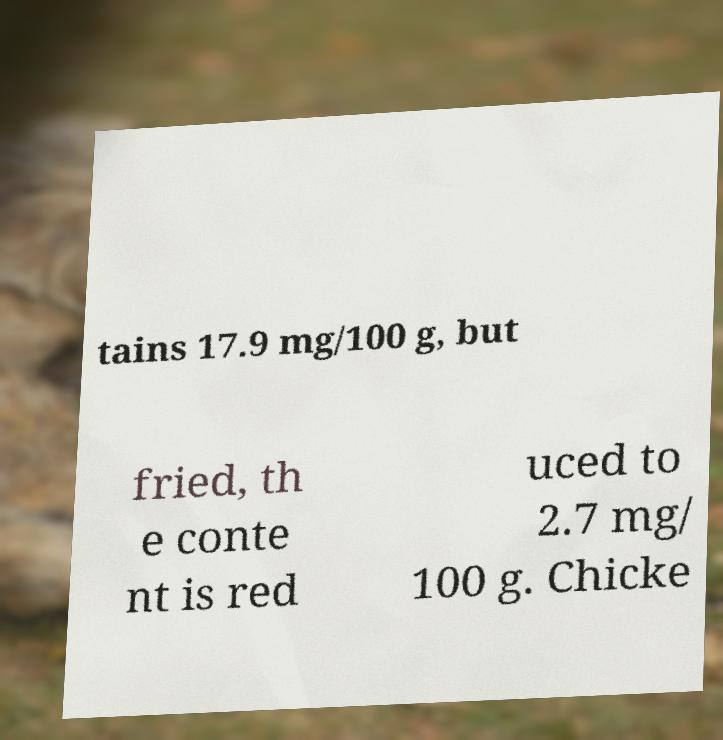Could you extract and type out the text from this image? tains 17.9 mg/100 g, but fried, th e conte nt is red uced to 2.7 mg/ 100 g. Chicke 